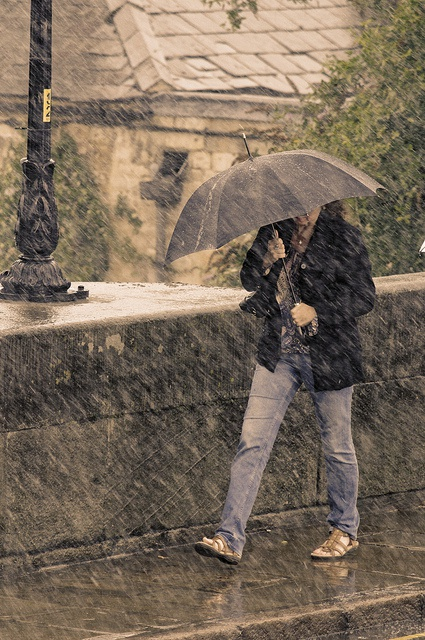Describe the objects in this image and their specific colors. I can see people in gray, black, and darkgray tones and umbrella in gray and tan tones in this image. 